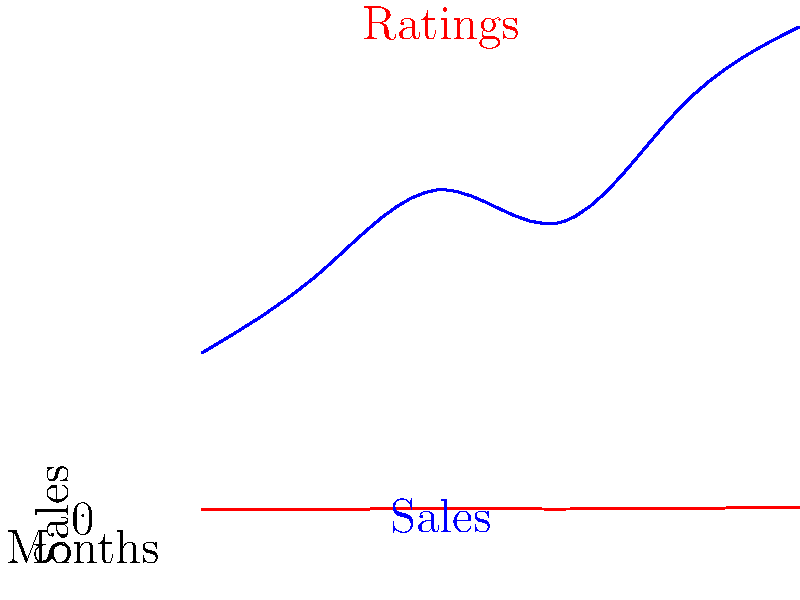As a self-published writer, you've been tracking your book sales and reader ratings over the past six months. The blue line represents sales, and the red line represents average reader ratings. Based on the graph, what correlation can you observe between sales and ratings, and how might this inform your writing strategy for your next novel? To answer this question, let's analyze the graph step-by-step:

1. Observe the trends:
   - Sales (blue line): Starts at 100 in month 1, rises to 200 in month 3, dips slightly in month 4, then increases sharply to 300 by month 6.
   - Ratings (red line): Starts at 3.5 in month 1 and shows a generally upward trend, reaching 4.7 by month 6.

2. Identify the correlation:
   - Both sales and ratings show an overall upward trend over the six months.
   - There's a slight dip in both sales and ratings around month 4, followed by a sharp increase.

3. Analyze the relationship:
   - The graph suggests a positive correlation between sales and ratings. As ratings improve, sales tend to increase as well.
   - The relationship isn't perfectly linear, but there's a clear association.

4. Interpret the data:
   - Higher ratings seem to lead to increased sales, possibly due to word-of-mouth recommendations or improved visibility on book platforms.
   - The dip in month 4 could represent a temporary setback or a specific event that affected both ratings and sales.

5. Inform writing strategy:
   - Focus on maintaining or improving the quality of your writing to keep ratings high.
   - Consider analyzing reader feedback from the periods with the highest ratings to identify what readers appreciate most about your work.
   - Pay attention to what might have caused the dip in month 4 and try to avoid similar issues in future books.
   - Use the upward trend as motivation to continue engaging with your readers and gathering feedback.
Answer: Positive correlation between ratings and sales; focus on quality to maintain high ratings and drive sales. 